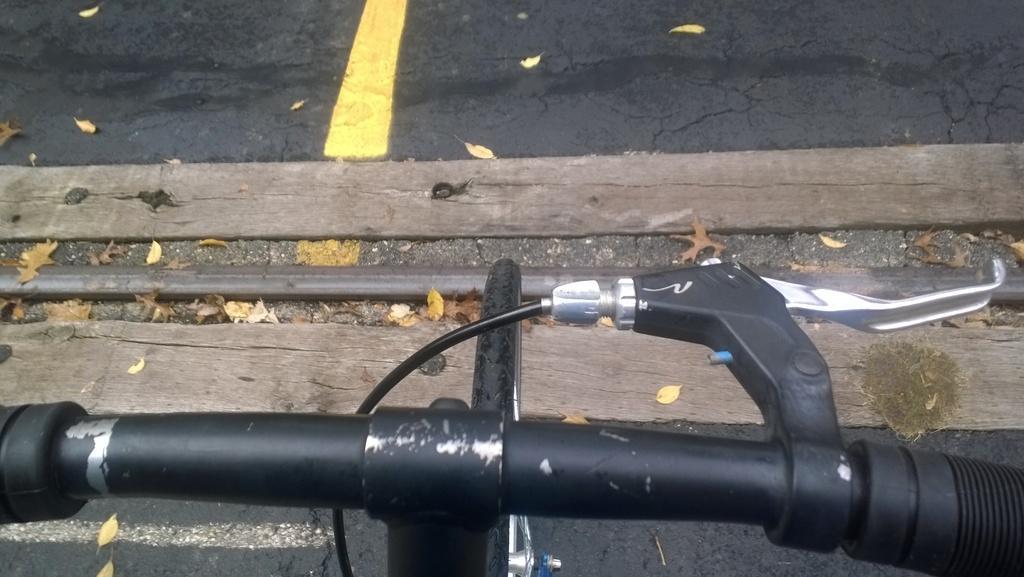Can you describe this image briefly? In this image in the foreground there is a bicycle. This is a road. On the ground there are dried leaves. 